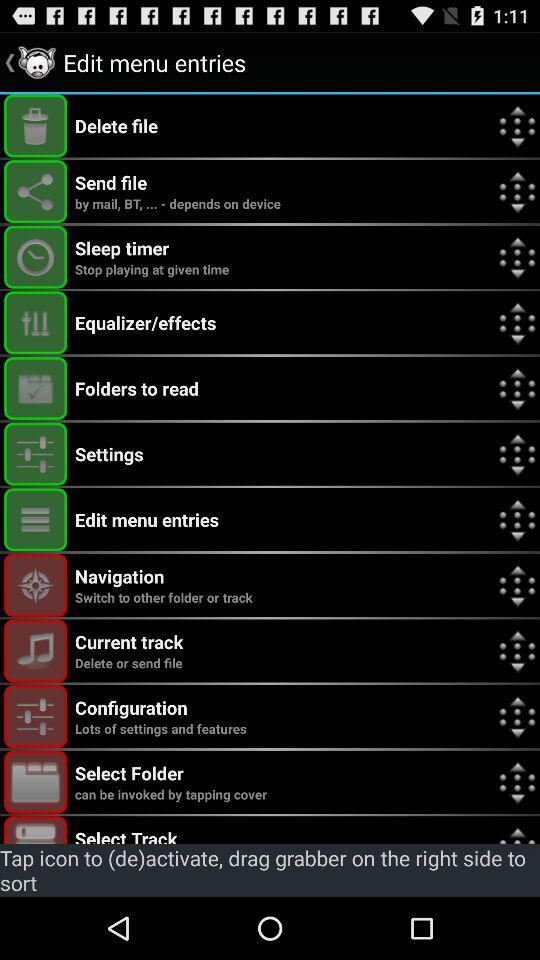How can a user send the file? A user can send files by mail and BT. 